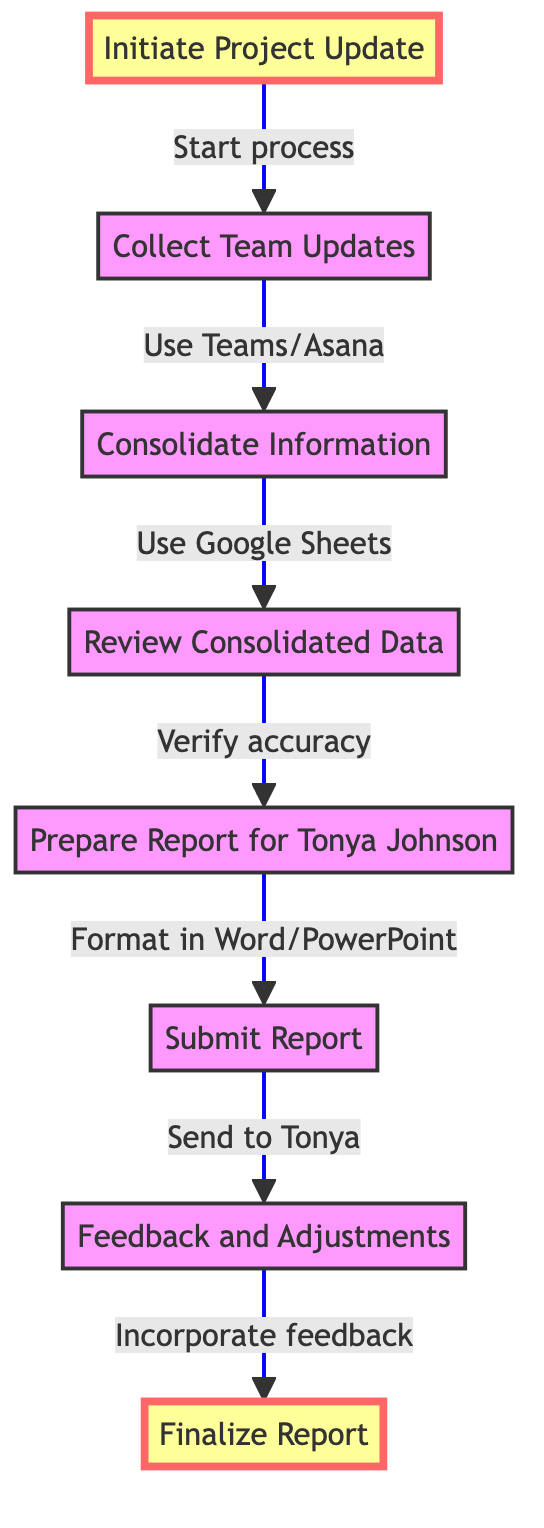What's the first step in the process? The first step in the diagram is labeled "Initiate Project Update," which indicates starting the process.
Answer: Initiate Project Update How many nodes are there in the diagram? The diagram contains a total of eight nodes, each representing a step in the process.
Answer: Eight What do you do after "Collect Team Updates"? After "Collect Team Updates," the next step is "Consolidate Information," which means compiling team updates.
Answer: Consolidate Information What tools are suggested for collecting team updates? The diagram mentions using tools like Microsoft Teams or Asana for collecting updates from the project teams.
Answer: Microsoft Teams or Asana What action follows "Submit Report"? The next action after "Submit Report" is "Feedback and Adjustments," indicating that Tonya Johnson will review the report.
Answer: Feedback and Adjustments Which step involves verification of data? The step labeled "Review Consolidated Data" involves verifying the accuracy and completeness of the gathered information.
Answer: Review Consolidated Data What is the final step in the process? The final step in the process is "Finalize Report," which occurs after incorporating feedback from Tonya Johnson.
Answer: Finalize Report What document formats are used for the report preparation? The diagram specifies that the report should be formatted using either Microsoft Word or PowerPoint.
Answer: Microsoft Word or PowerPoint What happens if feedback is provided by Tonya Johnson? If feedback is given by Tonya Johnson, necessary adjustments must be made and the report should be resubmitted, following the flow to the next step.
Answer: Make necessary adjustments and resubmit 